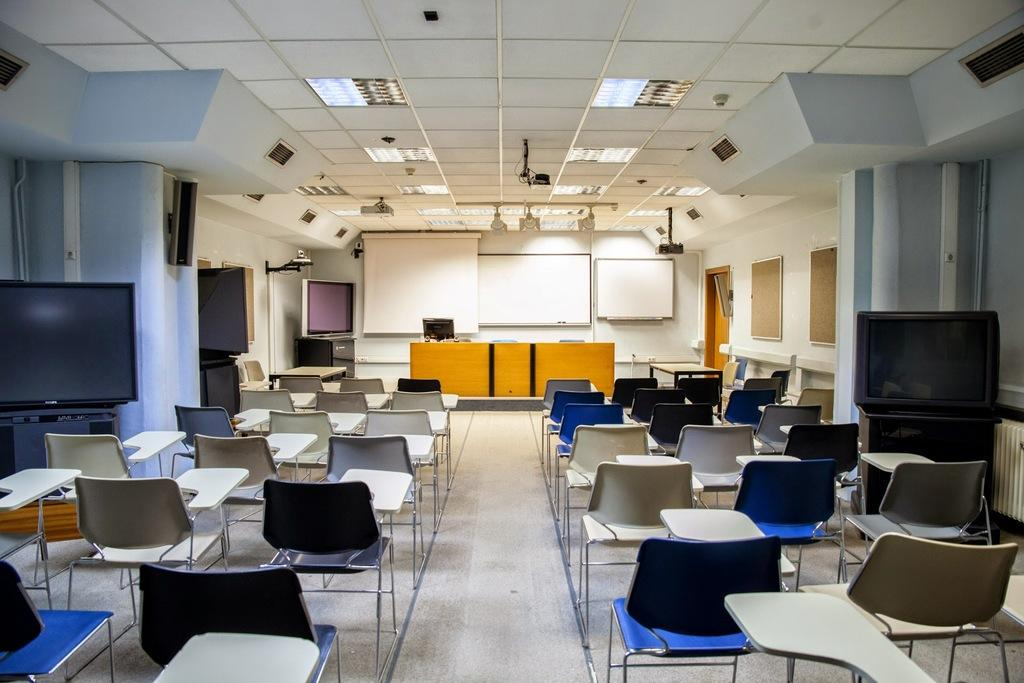What type of electronic devices can be found in the room? There are monitors, a camera, a projector, and speakers in the room. What furniture is available in the room? There are chairs and tables in the room. What is used for displaying information or presentations in the room? There is a screen in the room. What is used for writing or displaying notes in the room? There are boards in the room. How are the lights positioned in the room? Lights are attached to the ceiling. Where are the camera and speakers located in the room? The camera and speakers are on the wall. What type of thread is being used by the writer in the room? There is no writer or thread present in the room. Can you tell me how many uncles are in the room? There is no mention of an uncle or any family members in the room. 